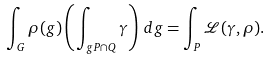<formula> <loc_0><loc_0><loc_500><loc_500>\int _ { G } \rho ( g ) \left ( \int _ { g P \cap Q } \gamma \right ) \, d g = \int _ { P } \mathcal { L } ( \gamma , \rho ) .</formula> 